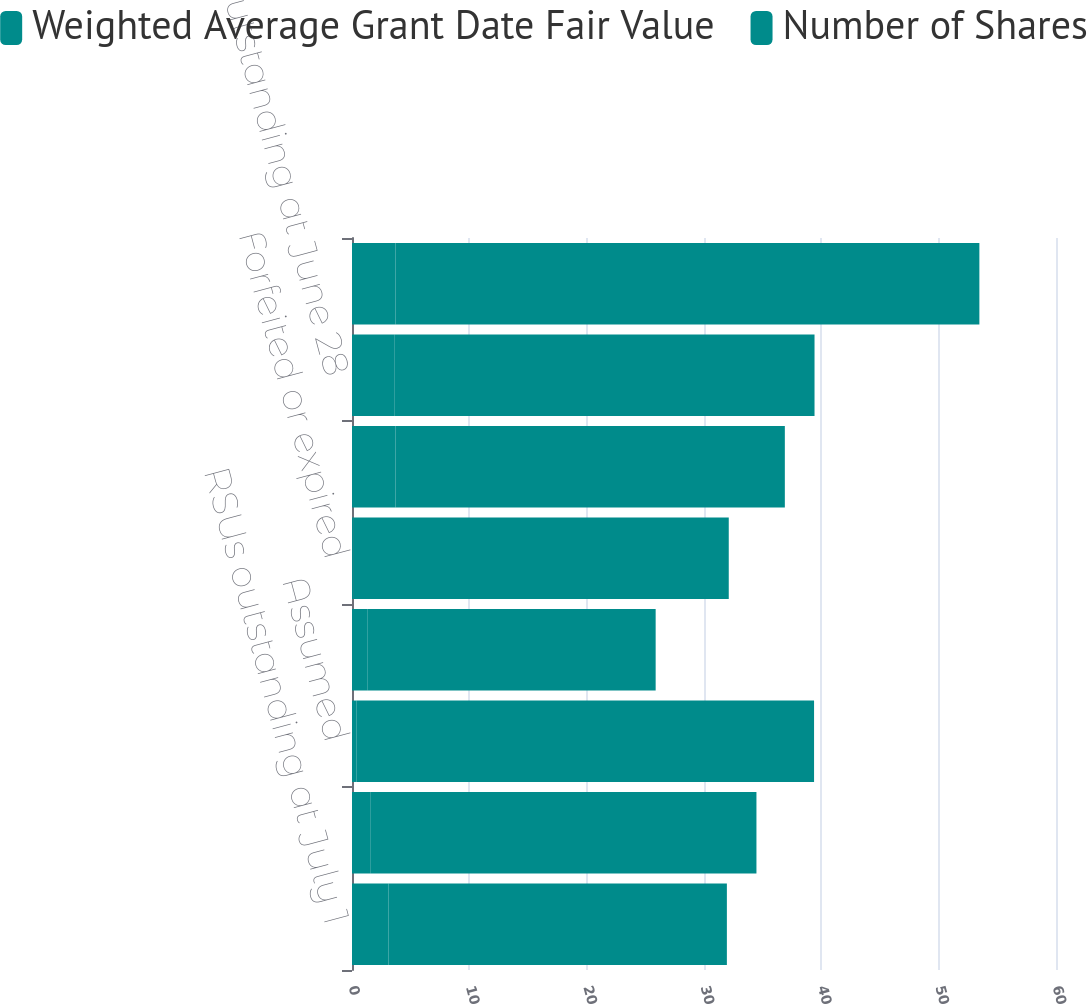Convert chart to OTSL. <chart><loc_0><loc_0><loc_500><loc_500><stacked_bar_chart><ecel><fcel>RSUs outstanding at July 1<fcel>Granted<fcel>Assumed<fcel>Vested<fcel>Forfeited or expired<fcel>RSUs outstanding at June 29<fcel>RSUs outstanding at June 28<fcel>RSUs outstanding at June 27<nl><fcel>Weighted Average Grant Date Fair Value<fcel>3.1<fcel>1.6<fcel>0.4<fcel>1.3<fcel>0.1<fcel>3.7<fcel>3.6<fcel>3.7<nl><fcel>Number of Shares<fcel>28.85<fcel>32.87<fcel>38.98<fcel>24.58<fcel>32.01<fcel>33.19<fcel>35.82<fcel>49.77<nl></chart> 